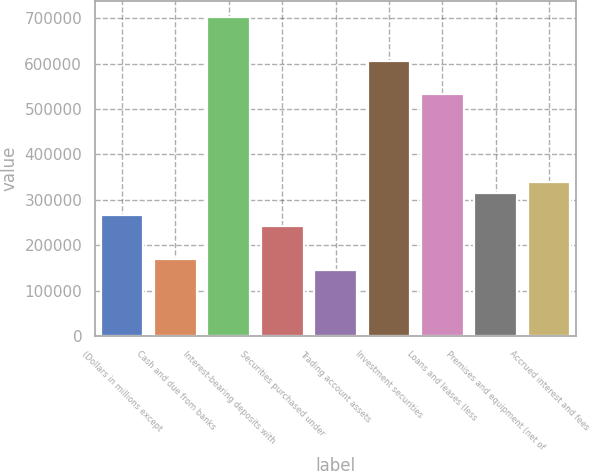Convert chart to OTSL. <chart><loc_0><loc_0><loc_500><loc_500><bar_chart><fcel>(Dollars in millions except<fcel>Cash and due from banks<fcel>Interest-bearing deposits with<fcel>Securities purchased under<fcel>Trading account assets<fcel>Investment securities<fcel>Loans and leases (less<fcel>Premises and equipment (net of<fcel>Accrued interest and fees<nl><fcel>266919<fcel>170036<fcel>702891<fcel>242698<fcel>145815<fcel>606008<fcel>533346<fcel>315360<fcel>339581<nl></chart> 